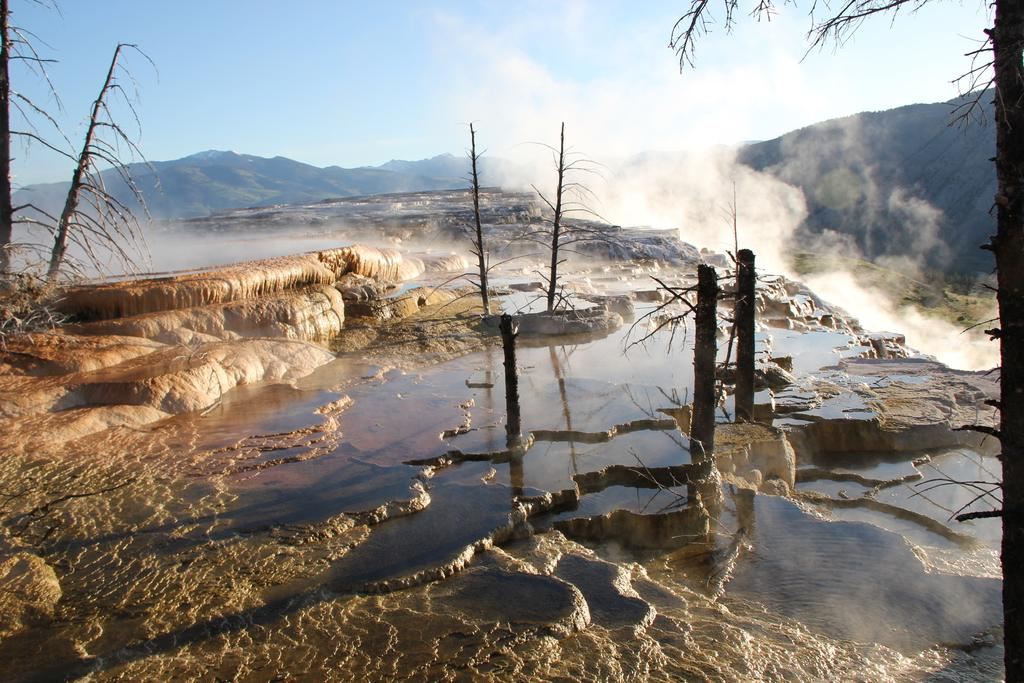What is present on the stone land in the foreground of the image? There is water on the stone land in the foreground of the image. What type of natural features can be seen in the image? There are rocks and trees without leaves visible in the image. How would you describe the overall appearance of the image? The image appears smoky. What type of landscape is depicted in the image? There are mountains in the image, indicating a mountainous landscape. What part of the natural environment is visible in the image? The sky is visible in the image. What type of marble is used to construct the board in the image? There is no board or marble present in the image. How does the temper of the trees affect the overall mood of the image? There are no trees with temper in the image; the trees depicted are without leaves. 